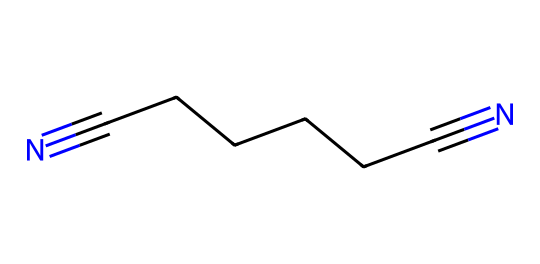What is the main structural feature of adiponitrile? The main structural feature is the two nitrile groups (–C≡N) at each end of the carbon chain, indicating it is a linear chain with two terminal nitrile functionalities.
Answer: two nitrile groups How many carbon atoms are in adiponitrile? By counting the carbon atoms in the linear chain (CCCCCC), we find there are six carbon atoms in total.
Answer: six What type of chemical is adiponitrile? Adiponitrile is classified as a nitrile due to the presence of the cyano groups (–C≡N) in its structure.
Answer: nitrile What is the total number of bonds in adiponitrile? The structure contains six carbon-carbon single bonds (C-C) and two carbon-nitrogen triple bonds (C≡N), totaling eight bonds.
Answer: eight Which atoms contribute to the linearity of adiponitrile's structure? The carbon atoms linked by single bonds C-C contribute to the linearity, while the terminal nitrile groups ensure it remains a straight chain.
Answer: carbon atoms What is the significance of adiponitrile in the context of nylon production? Adiponitrile is a key precursor in the production of nylon 66, providing the necessary diacid and diamine functionalities through its structure.
Answer: precursor of nylon 66 